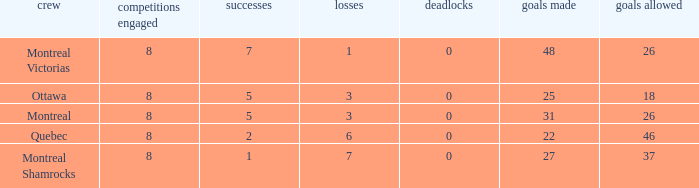For teams with more than 0 ties and goals against of 37, how many wins were tallied? None. Give me the full table as a dictionary. {'header': ['crew', 'competitions engaged', 'successes', 'losses', 'deadlocks', 'goals made', 'goals allowed'], 'rows': [['Montreal Victorias', '8', '7', '1', '0', '48', '26'], ['Ottawa', '8', '5', '3', '0', '25', '18'], ['Montreal', '8', '5', '3', '0', '31', '26'], ['Quebec', '8', '2', '6', '0', '22', '46'], ['Montreal Shamrocks', '8', '1', '7', '0', '27', '37']]} 